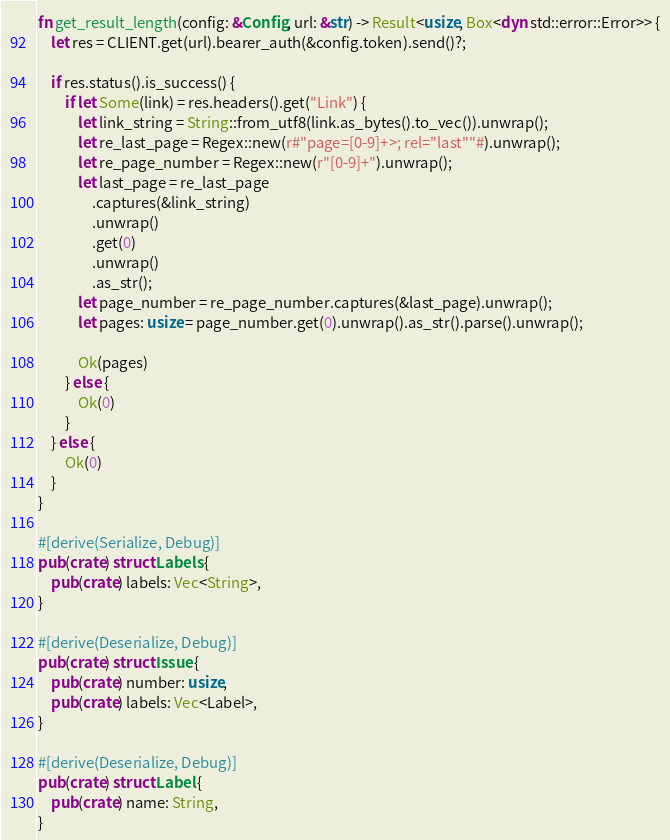Convert code to text. <code><loc_0><loc_0><loc_500><loc_500><_Rust_>fn get_result_length(config: &Config, url: &str) -> Result<usize, Box<dyn std::error::Error>> {
    let res = CLIENT.get(url).bearer_auth(&config.token).send()?;

    if res.status().is_success() {
        if let Some(link) = res.headers().get("Link") {
            let link_string = String::from_utf8(link.as_bytes().to_vec()).unwrap();
            let re_last_page = Regex::new(r#"page=[0-9]+>; rel="last""#).unwrap();
            let re_page_number = Regex::new(r"[0-9]+").unwrap();
            let last_page = re_last_page
                .captures(&link_string)
                .unwrap()
                .get(0)
                .unwrap()
                .as_str();
            let page_number = re_page_number.captures(&last_page).unwrap();
            let pages: usize = page_number.get(0).unwrap().as_str().parse().unwrap();

            Ok(pages)
        } else {
            Ok(0)
        }
    } else {
        Ok(0)
    }
}

#[derive(Serialize, Debug)]
pub(crate) struct Labels {
    pub(crate) labels: Vec<String>,
}

#[derive(Deserialize, Debug)]
pub(crate) struct Issue {
    pub(crate) number: usize,
    pub(crate) labels: Vec<Label>,
}

#[derive(Deserialize, Debug)]
pub(crate) struct Label {
    pub(crate) name: String,
}
</code> 